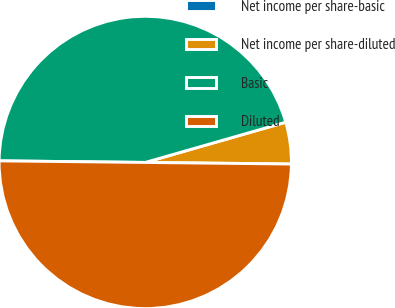Convert chart. <chart><loc_0><loc_0><loc_500><loc_500><pie_chart><fcel>Net income per share-basic<fcel>Net income per share-diluted<fcel>Basic<fcel>Diluted<nl><fcel>0.0%<fcel>4.61%<fcel>45.39%<fcel>50.0%<nl></chart> 